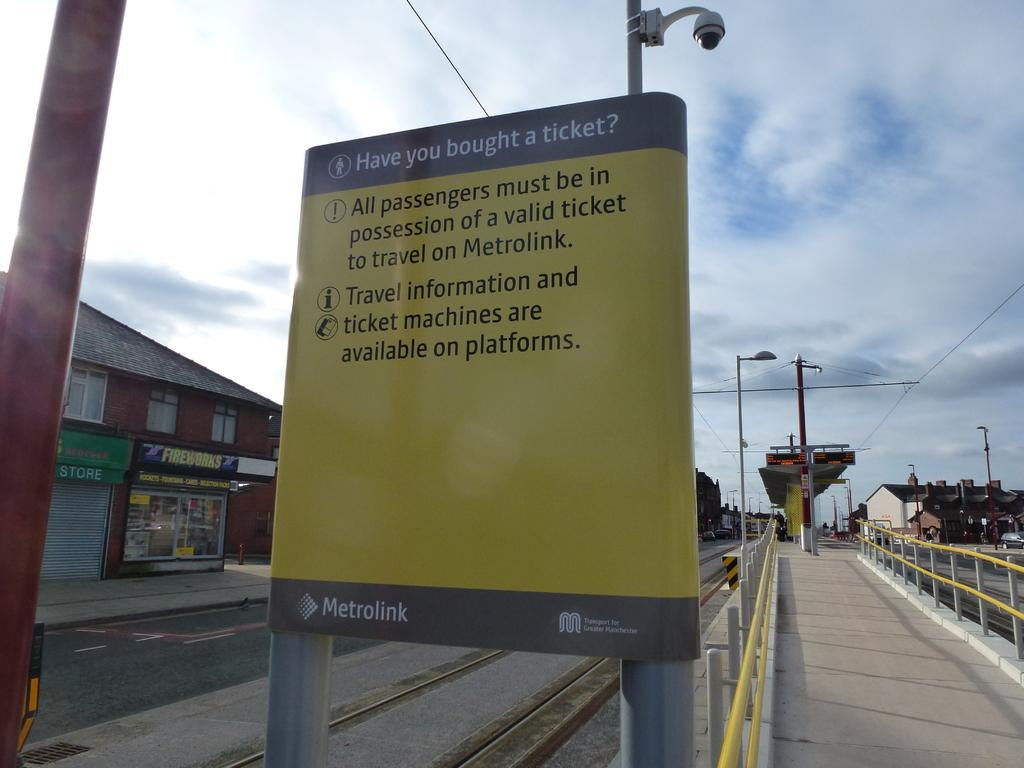<image>
Create a compact narrative representing the image presented. A yellow sign for Metrolink reminds passengers they must all be in possession of a valid ticket to travel 